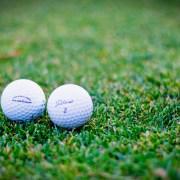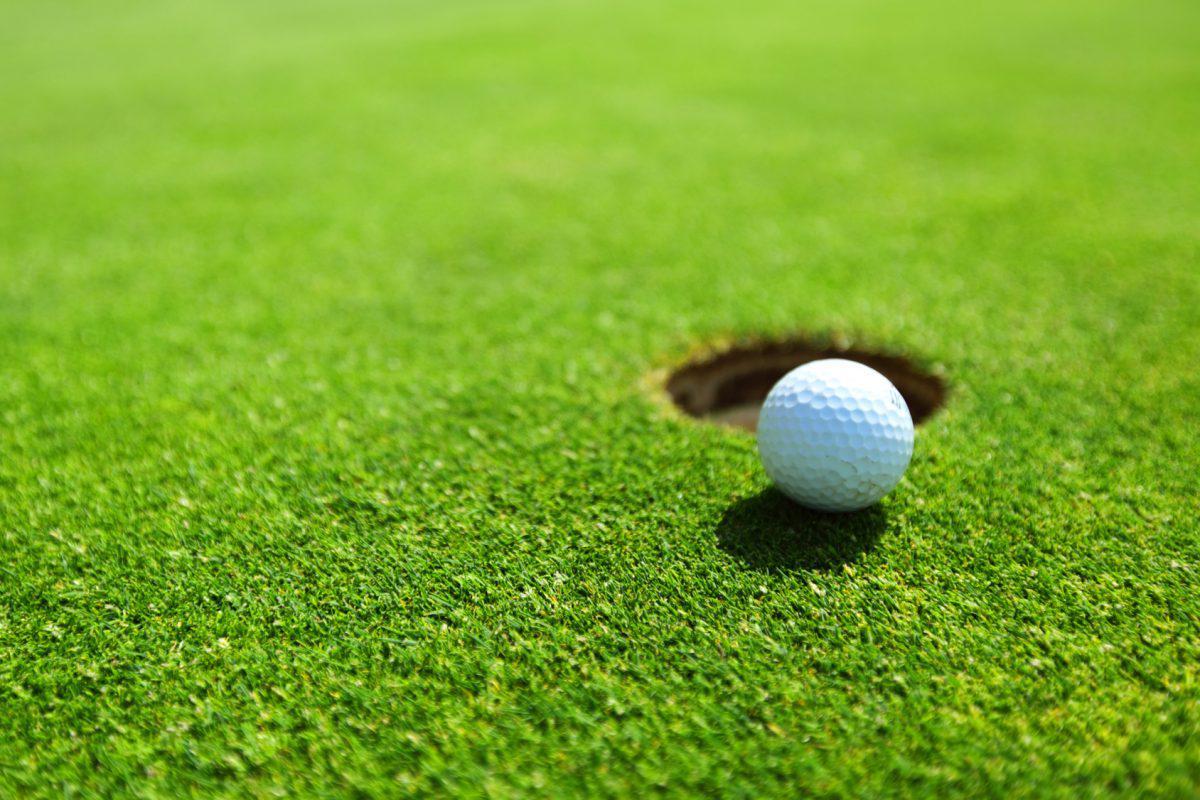The first image is the image on the left, the second image is the image on the right. Analyze the images presented: Is the assertion "There is one golf ball resting next to a hole in the image on the right" valid? Answer yes or no. Yes. 